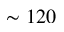Convert formula to latex. <formula><loc_0><loc_0><loc_500><loc_500>\sim 1 2 0</formula> 